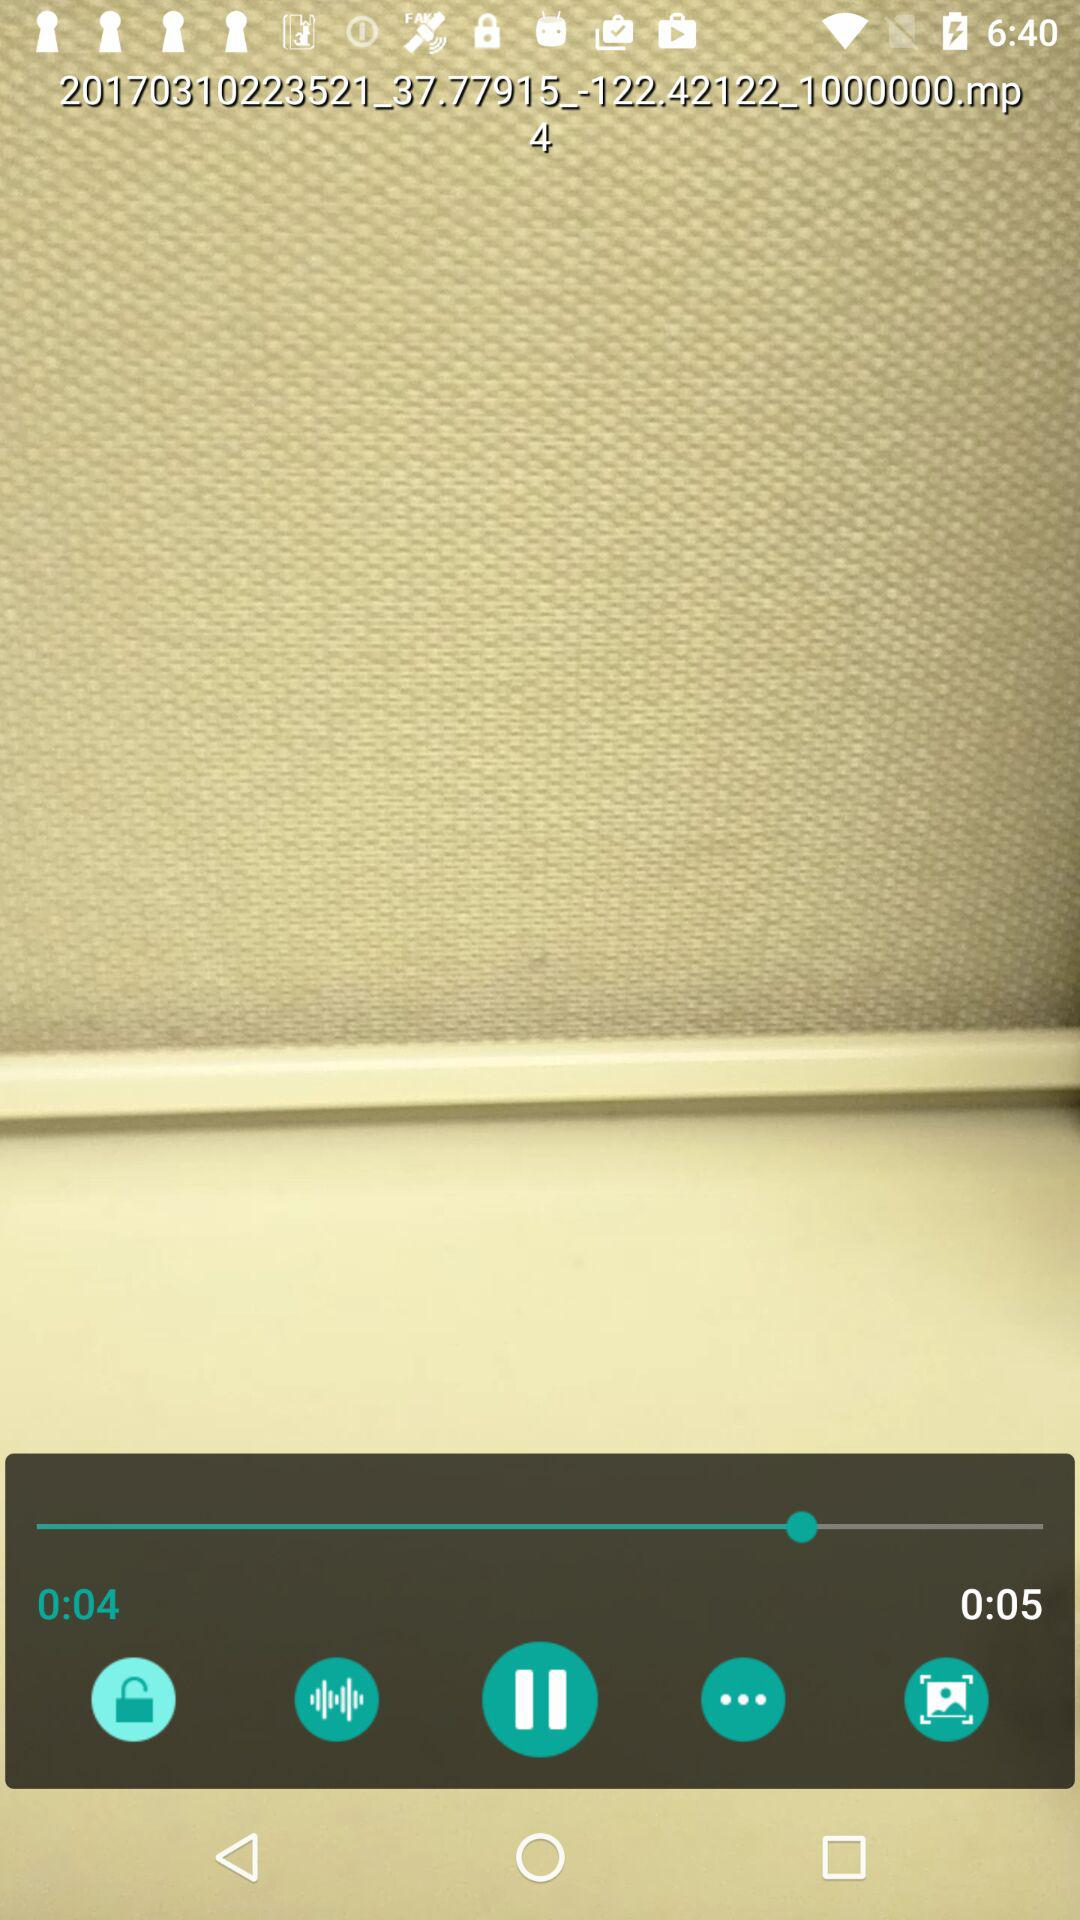For how long has the video been played? The video has been played for 4 seconds. 